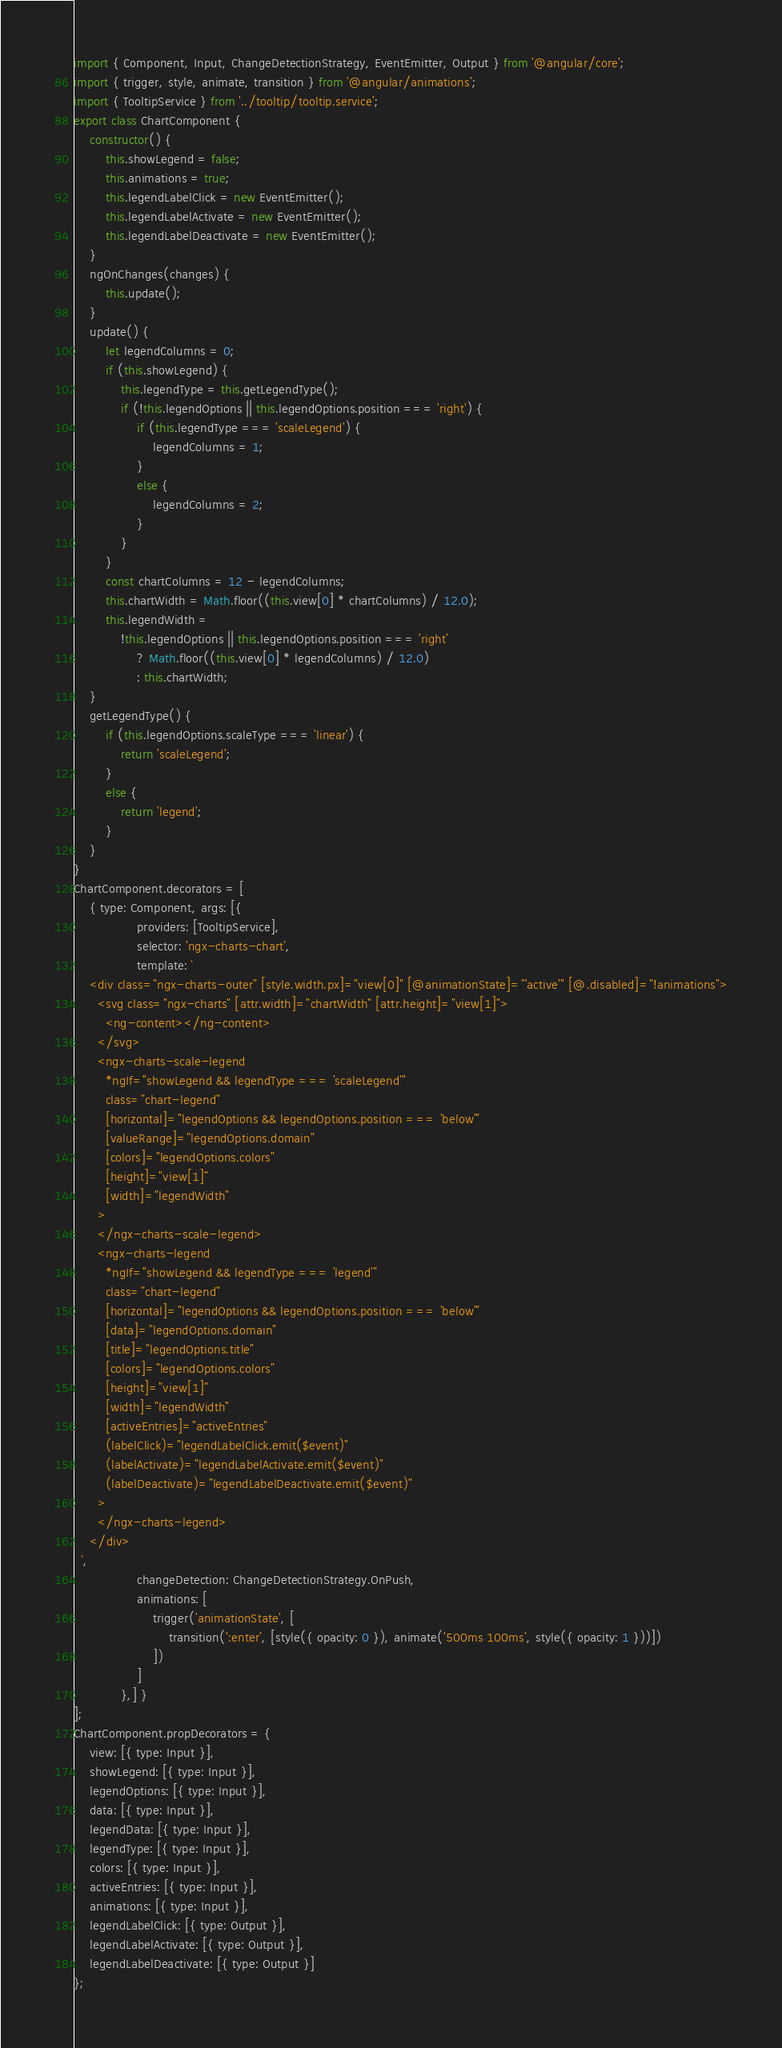<code> <loc_0><loc_0><loc_500><loc_500><_JavaScript_>import { Component, Input, ChangeDetectionStrategy, EventEmitter, Output } from '@angular/core';
import { trigger, style, animate, transition } from '@angular/animations';
import { TooltipService } from '../tooltip/tooltip.service';
export class ChartComponent {
    constructor() {
        this.showLegend = false;
        this.animations = true;
        this.legendLabelClick = new EventEmitter();
        this.legendLabelActivate = new EventEmitter();
        this.legendLabelDeactivate = new EventEmitter();
    }
    ngOnChanges(changes) {
        this.update();
    }
    update() {
        let legendColumns = 0;
        if (this.showLegend) {
            this.legendType = this.getLegendType();
            if (!this.legendOptions || this.legendOptions.position === 'right') {
                if (this.legendType === 'scaleLegend') {
                    legendColumns = 1;
                }
                else {
                    legendColumns = 2;
                }
            }
        }
        const chartColumns = 12 - legendColumns;
        this.chartWidth = Math.floor((this.view[0] * chartColumns) / 12.0);
        this.legendWidth =
            !this.legendOptions || this.legendOptions.position === 'right'
                ? Math.floor((this.view[0] * legendColumns) / 12.0)
                : this.chartWidth;
    }
    getLegendType() {
        if (this.legendOptions.scaleType === 'linear') {
            return 'scaleLegend';
        }
        else {
            return 'legend';
        }
    }
}
ChartComponent.decorators = [
    { type: Component, args: [{
                providers: [TooltipService],
                selector: 'ngx-charts-chart',
                template: `
    <div class="ngx-charts-outer" [style.width.px]="view[0]" [@animationState]="'active'" [@.disabled]="!animations">
      <svg class="ngx-charts" [attr.width]="chartWidth" [attr.height]="view[1]">
        <ng-content></ng-content>
      </svg>
      <ngx-charts-scale-legend
        *ngIf="showLegend && legendType === 'scaleLegend'"
        class="chart-legend"
        [horizontal]="legendOptions && legendOptions.position === 'below'"
        [valueRange]="legendOptions.domain"
        [colors]="legendOptions.colors"
        [height]="view[1]"
        [width]="legendWidth"
      >
      </ngx-charts-scale-legend>
      <ngx-charts-legend
        *ngIf="showLegend && legendType === 'legend'"
        class="chart-legend"
        [horizontal]="legendOptions && legendOptions.position === 'below'"
        [data]="legendOptions.domain"
        [title]="legendOptions.title"
        [colors]="legendOptions.colors"
        [height]="view[1]"
        [width]="legendWidth"
        [activeEntries]="activeEntries"
        (labelClick)="legendLabelClick.emit($event)"
        (labelActivate)="legendLabelActivate.emit($event)"
        (labelDeactivate)="legendLabelDeactivate.emit($event)"
      >
      </ngx-charts-legend>
    </div>
  `,
                changeDetection: ChangeDetectionStrategy.OnPush,
                animations: [
                    trigger('animationState', [
                        transition(':enter', [style({ opacity: 0 }), animate('500ms 100ms', style({ opacity: 1 }))])
                    ])
                ]
            },] }
];
ChartComponent.propDecorators = {
    view: [{ type: Input }],
    showLegend: [{ type: Input }],
    legendOptions: [{ type: Input }],
    data: [{ type: Input }],
    legendData: [{ type: Input }],
    legendType: [{ type: Input }],
    colors: [{ type: Input }],
    activeEntries: [{ type: Input }],
    animations: [{ type: Input }],
    legendLabelClick: [{ type: Output }],
    legendLabelActivate: [{ type: Output }],
    legendLabelDeactivate: [{ type: Output }]
};</code> 